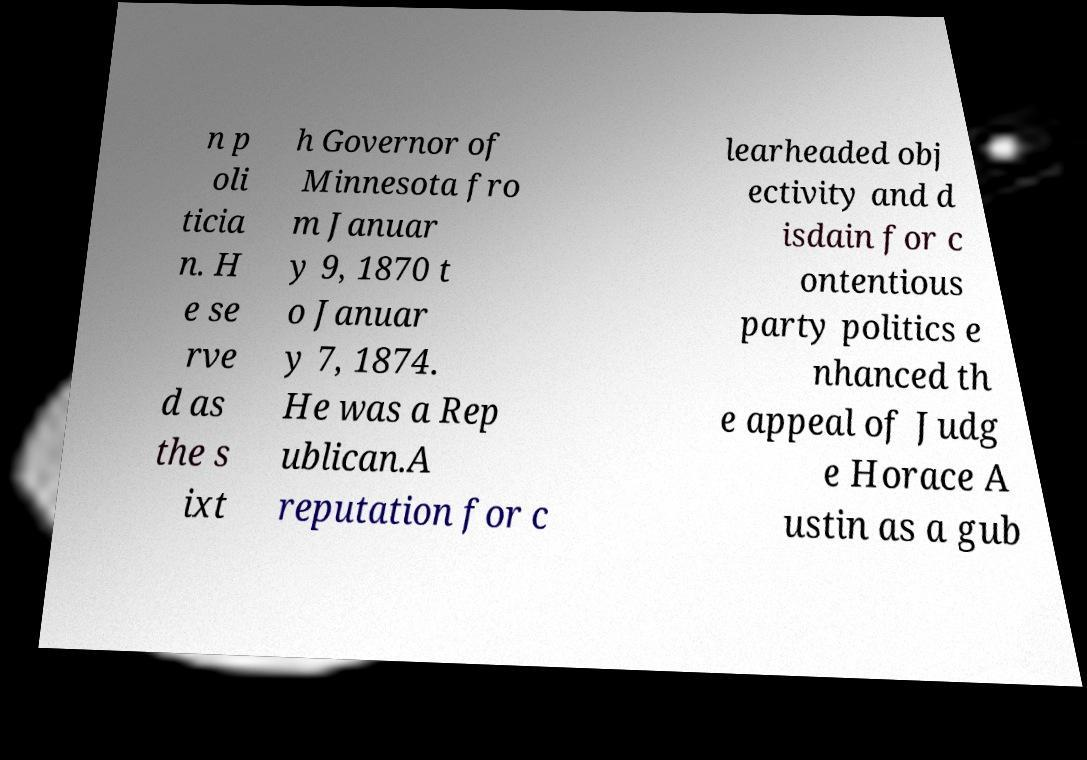There's text embedded in this image that I need extracted. Can you transcribe it verbatim? n p oli ticia n. H e se rve d as the s ixt h Governor of Minnesota fro m Januar y 9, 1870 t o Januar y 7, 1874. He was a Rep ublican.A reputation for c learheaded obj ectivity and d isdain for c ontentious party politics e nhanced th e appeal of Judg e Horace A ustin as a gub 